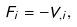<formula> <loc_0><loc_0><loc_500><loc_500>F _ { i } = - V _ { , i } ,</formula> 